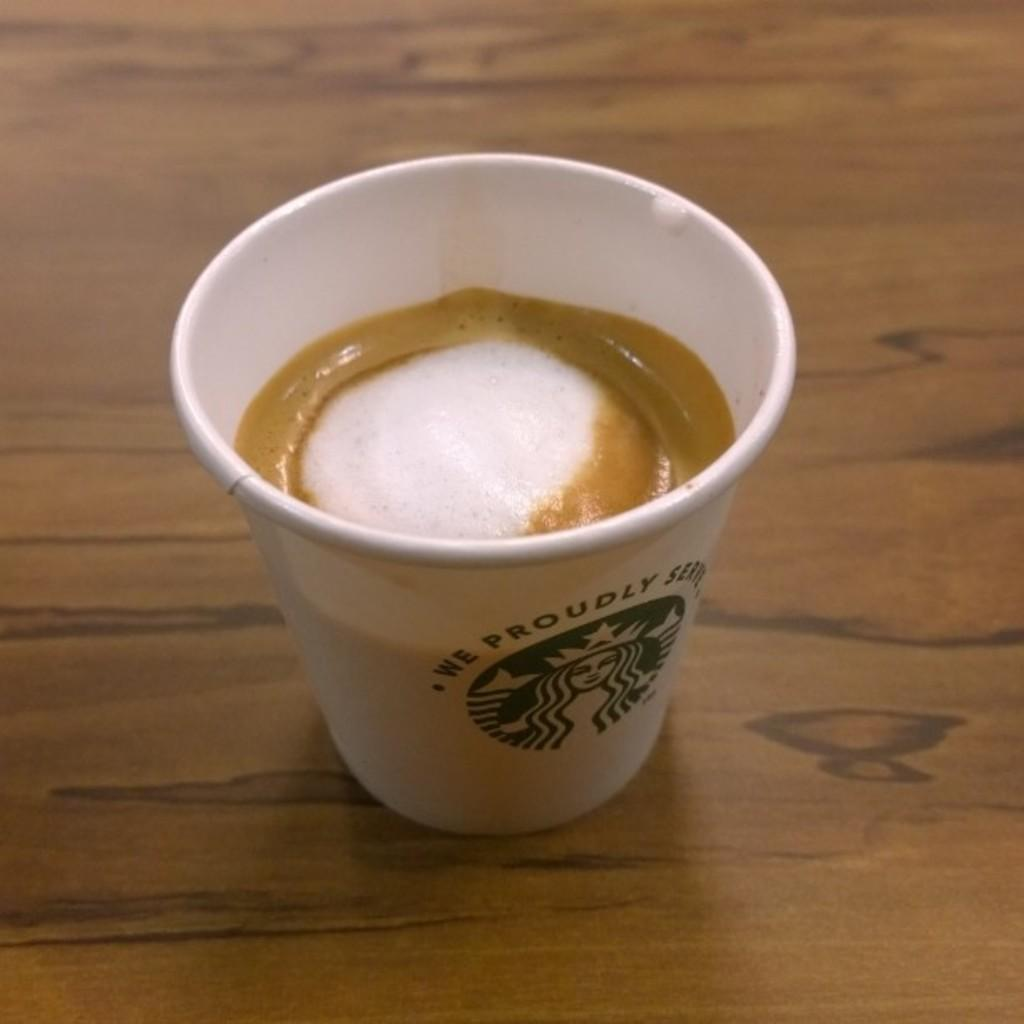What is in the cup that is visible in the image? There is coffee in the cup in the image. Where is the cup located in the image? The cup is in the center of the image. What is present at the bottom of the image? There is a table at the bottom of the image. What type of soda is being washed in the mine in the image? There is no soda or mine present in the image; it only features a cup of coffee and a table. 